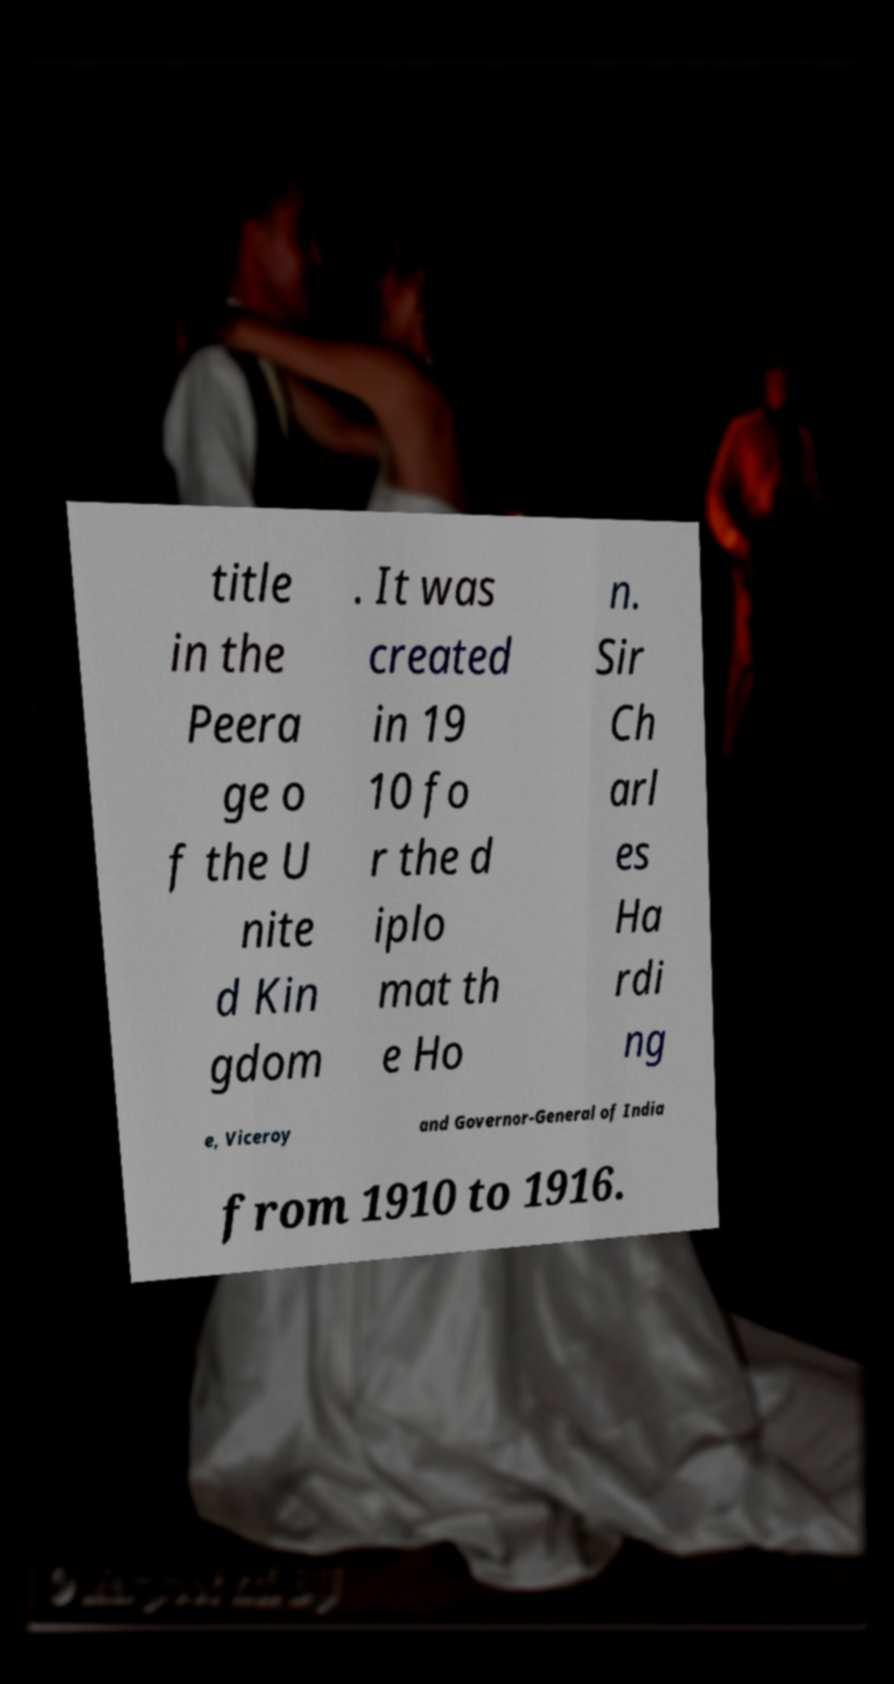Can you accurately transcribe the text from the provided image for me? title in the Peera ge o f the U nite d Kin gdom . It was created in 19 10 fo r the d iplo mat th e Ho n. Sir Ch arl es Ha rdi ng e, Viceroy and Governor-General of India from 1910 to 1916. 